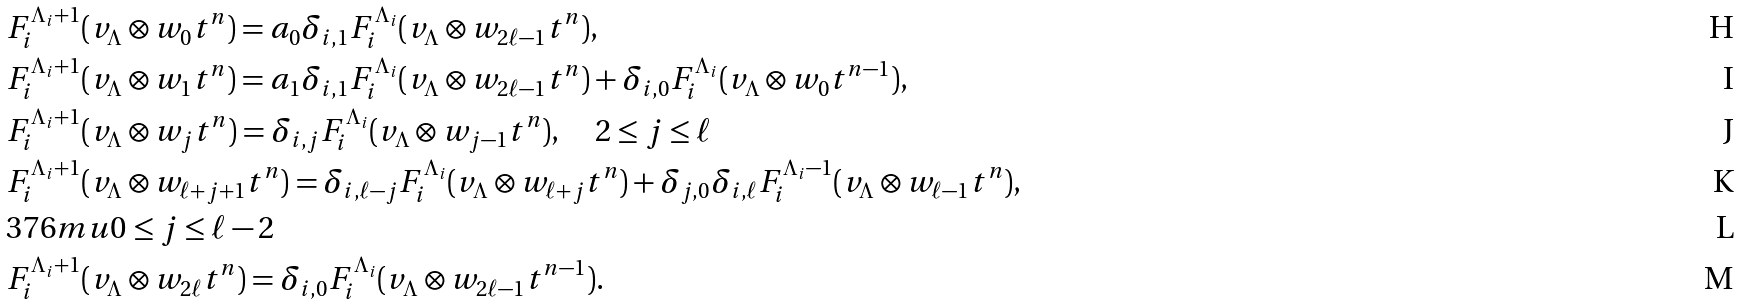<formula> <loc_0><loc_0><loc_500><loc_500>& F _ { i } ^ { \Lambda _ { i } + 1 } ( v _ { \Lambda } \otimes w _ { 0 } t ^ { n } ) = a _ { 0 } \delta _ { i , 1 } F _ { i } ^ { \Lambda _ { i } } ( v _ { \Lambda } \otimes w _ { 2 \ell - 1 } t ^ { n } ) , \\ & F _ { i } ^ { \Lambda _ { i } + 1 } ( v _ { \Lambda } \otimes w _ { 1 } t ^ { n } ) = a _ { 1 } \delta _ { i , 1 } F _ { i } ^ { \Lambda _ { i } } ( v _ { \Lambda } \otimes w _ { 2 \ell - 1 } t ^ { n } ) + \delta _ { i , 0 } F _ { i } ^ { \Lambda _ { i } } ( v _ { \Lambda } \otimes w _ { 0 } t ^ { n - 1 } ) , \\ & F _ { i } ^ { \Lambda _ { i } + 1 } ( v _ { \Lambda } \otimes w _ { j } t ^ { n } ) = \delta _ { i , j } F _ { i } ^ { \Lambda _ { i } } ( v _ { \Lambda } \otimes w _ { j - 1 } t ^ { n } ) , \quad 2 \leq j \leq \ell \\ & F _ { i } ^ { \Lambda _ { i } + 1 } ( v _ { \Lambda } \otimes w _ { \ell + j + 1 } t ^ { n } ) = \delta _ { i , \ell - j } F _ { i } ^ { \Lambda _ { i } } ( v _ { \Lambda } \otimes w _ { \ell + j } t ^ { n } ) + \delta _ { j , 0 } \delta _ { i , \ell } F _ { i } ^ { \Lambda _ { i } - 1 } ( v _ { \Lambda } \otimes w _ { \ell - 1 } t ^ { n } ) , \\ & 3 7 6 m u 0 \leq j \leq \ell - 2 \\ & F _ { i } ^ { \Lambda _ { i } + 1 } ( v _ { \Lambda } \otimes w _ { 2 \ell } t ^ { n } ) = \delta _ { i , 0 } F _ { i } ^ { \Lambda _ { i } } ( v _ { \Lambda } \otimes w _ { 2 \ell - 1 } t ^ { n - 1 } ) .</formula> 